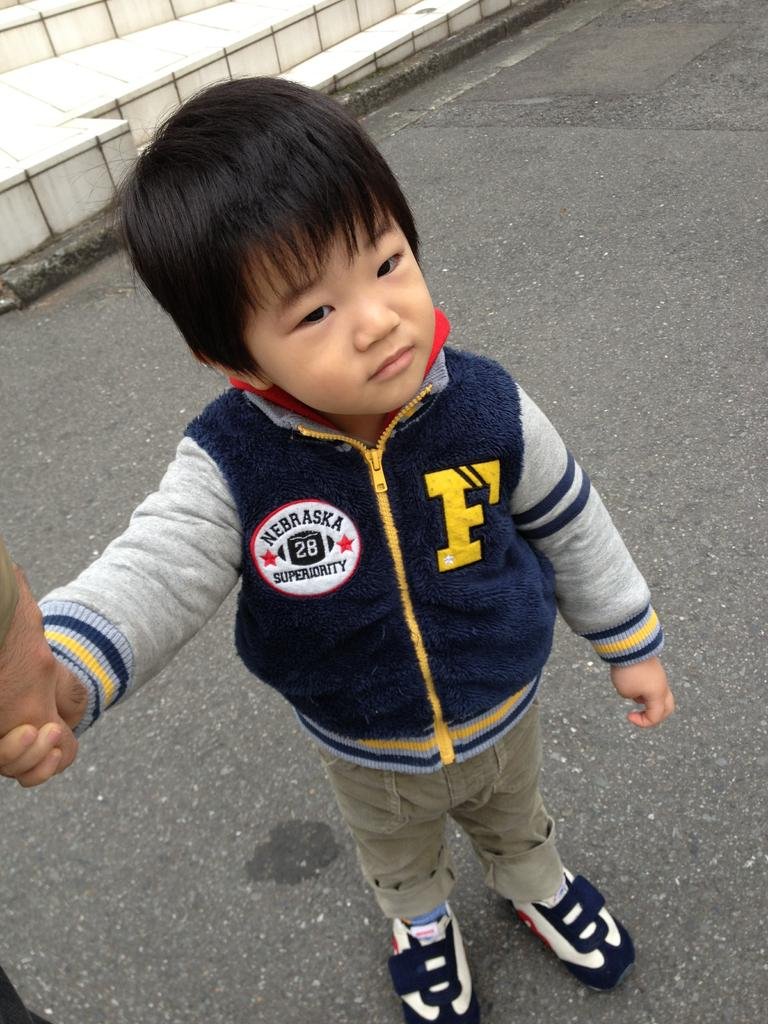<image>
Present a compact description of the photo's key features. A little boy wearing a Nebraska Superiority jacket. 